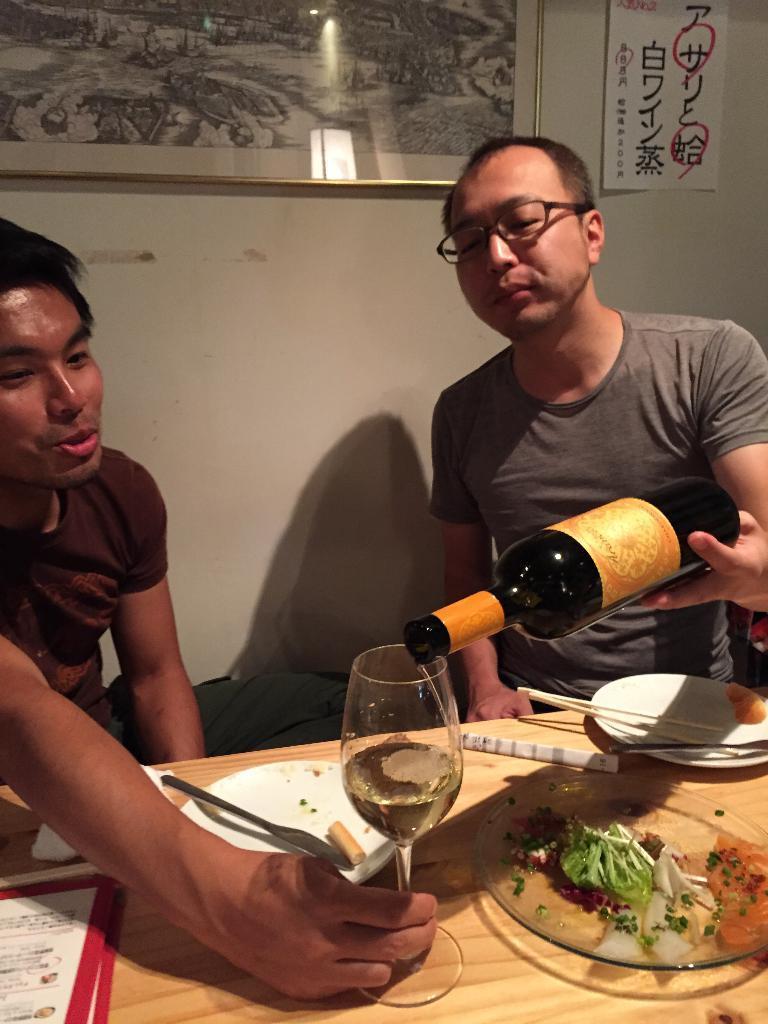Please provide a concise description of this image. In this picture there are two men sitting at a table. The man to the right corner is holding wine bottle in his hand and serving drink. The man to the left corner is holding a wine glass in his hand. On the table there are plates, chopsticks, knife and papers. In the background there is wall, a picture frame and a poster with text on it. 